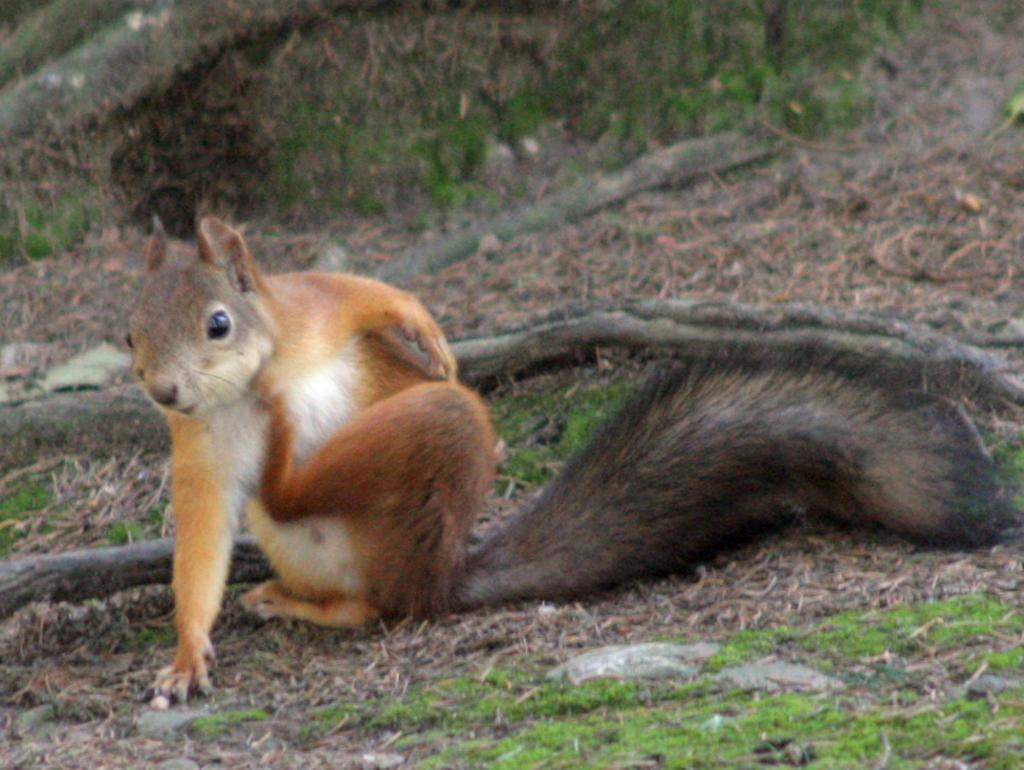What animal can be seen in the image? There is a squirrel in the image. Where is the squirrel located? The squirrel is on the grassland. What else can be seen in the image besides the squirrel? There are branches of a tree visible in the image. What type of cart is being pulled by the squirrel in the image? There is no cart present in the image; it features a squirrel on the grassland with branches of a tree visible. 